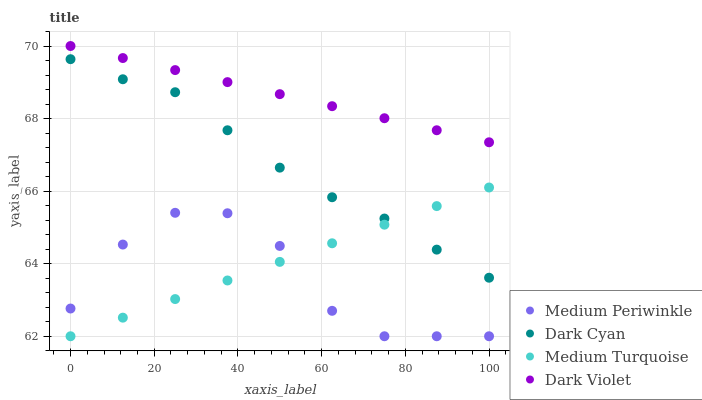Does Medium Periwinkle have the minimum area under the curve?
Answer yes or no. Yes. Does Dark Violet have the maximum area under the curve?
Answer yes or no. Yes. Does Dark Violet have the minimum area under the curve?
Answer yes or no. No. Does Medium Periwinkle have the maximum area under the curve?
Answer yes or no. No. Is Medium Turquoise the smoothest?
Answer yes or no. Yes. Is Medium Periwinkle the roughest?
Answer yes or no. Yes. Is Dark Violet the smoothest?
Answer yes or no. No. Is Dark Violet the roughest?
Answer yes or no. No. Does Medium Periwinkle have the lowest value?
Answer yes or no. Yes. Does Dark Violet have the lowest value?
Answer yes or no. No. Does Dark Violet have the highest value?
Answer yes or no. Yes. Does Medium Periwinkle have the highest value?
Answer yes or no. No. Is Medium Periwinkle less than Dark Cyan?
Answer yes or no. Yes. Is Dark Violet greater than Medium Periwinkle?
Answer yes or no. Yes. Does Medium Periwinkle intersect Medium Turquoise?
Answer yes or no. Yes. Is Medium Periwinkle less than Medium Turquoise?
Answer yes or no. No. Is Medium Periwinkle greater than Medium Turquoise?
Answer yes or no. No. Does Medium Periwinkle intersect Dark Cyan?
Answer yes or no. No. 